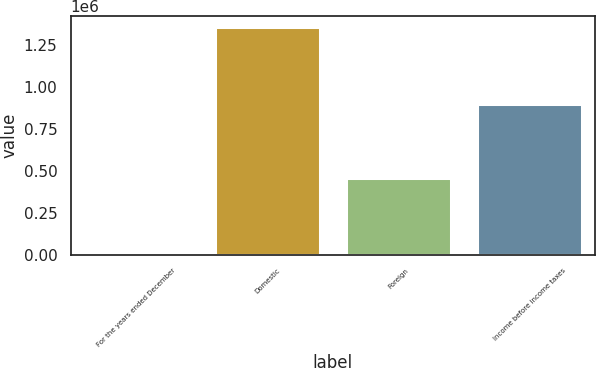Convert chart to OTSL. <chart><loc_0><loc_0><loc_500><loc_500><bar_chart><fcel>For the years ended December<fcel>Domestic<fcel>Foreign<fcel>Income before income taxes<nl><fcel>2015<fcel>1.35762e+06<fcel>455771<fcel>901847<nl></chart> 